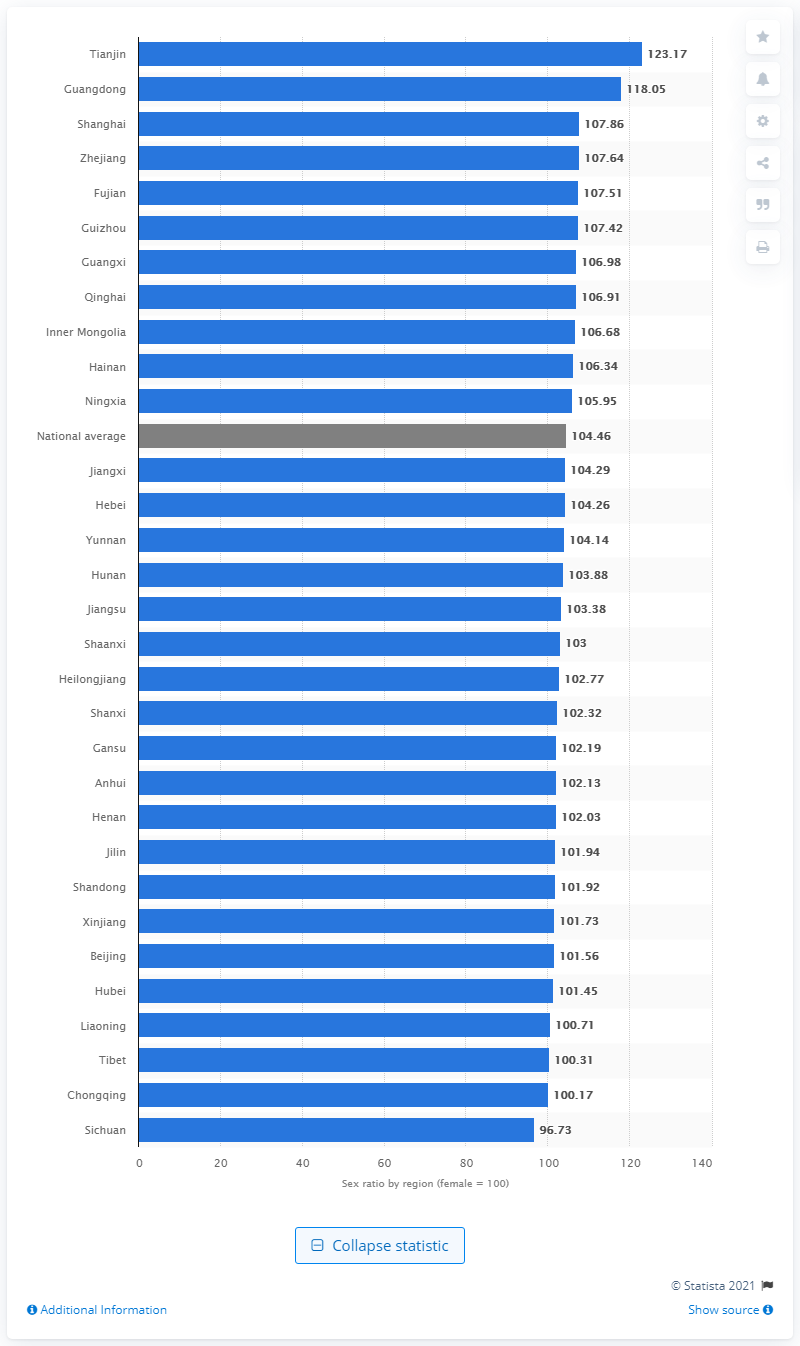Draw attention to some important aspects in this diagram. In 2019, the gender ratio in Sichuan was 96.73%. In 2019, the national gender ratio of men to women was 104.46. In 2019, the gender ratio in Tianjin Municipality was 123.17. 